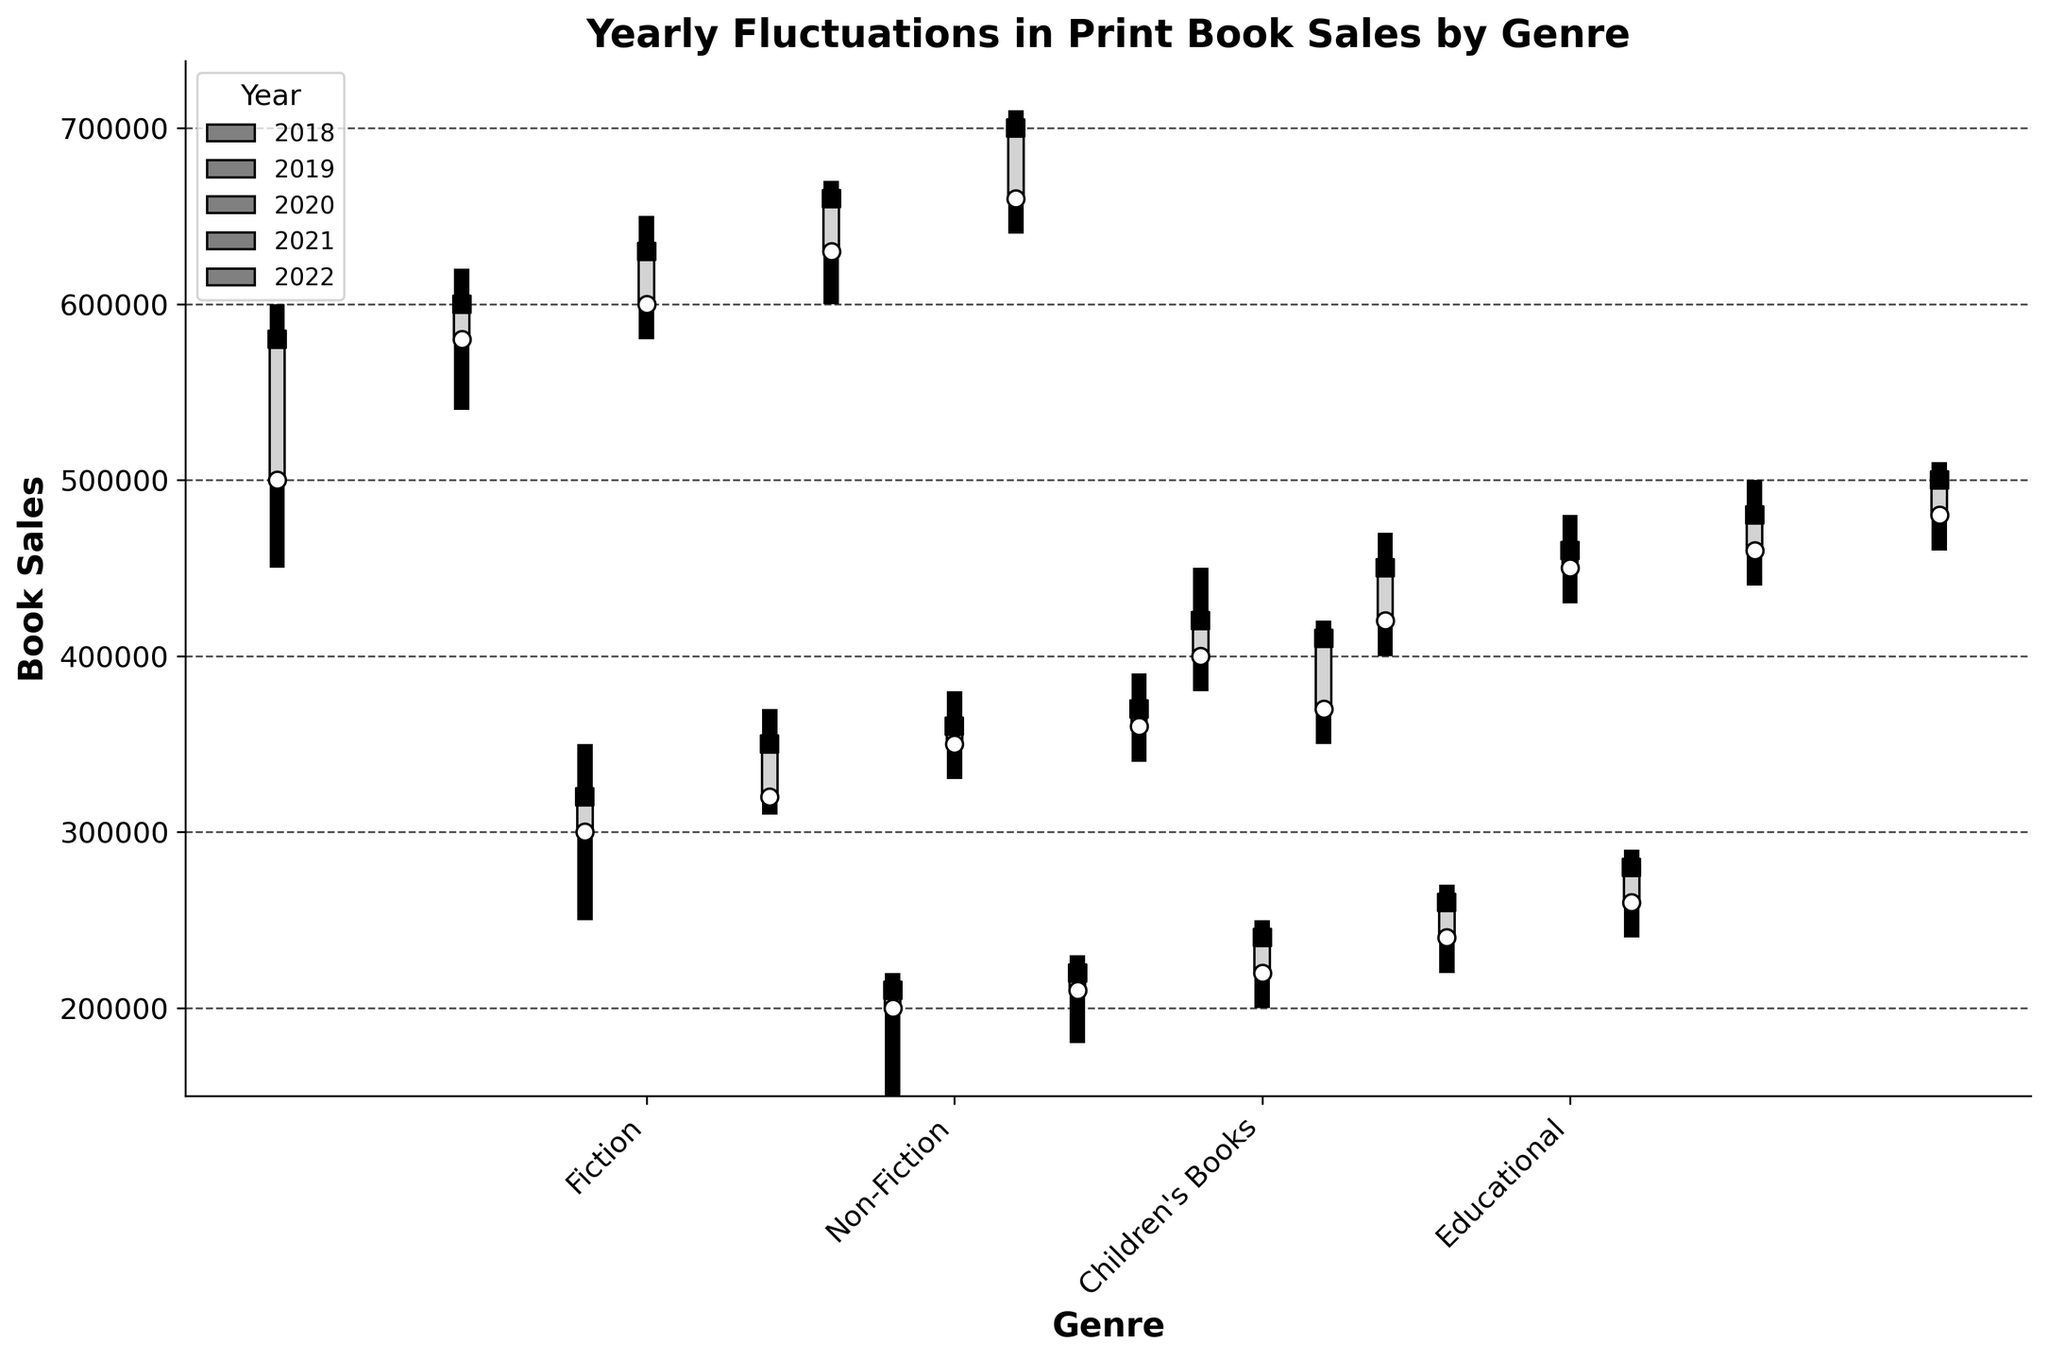What's the title of the plot? The title is indicated at the top of the plot.
Answer: Yearly Fluctuations in Print Book Sales by Genre What is the y-axis label? The y-axis label is shown on the left side of the plot.
Answer: Book Sales What genre had the highest sales in 2022? By examining the candlesticks for 2022, the genre with the highest close value is noted. Fiction ended at 700,000, which is the highest.
Answer: Fiction In which year did Educational books have the lowest close value? Look at the close values (square markers) for Educational across all years. The lowest close value is in 2018 and is 420,000.
Answer: 2018 Did Children's Books sales increase or decrease between 2021 and 2022? Compare the close values for Children's Books in 2021 (260,000) and 2022 (280,000). The sales increased.
Answer: Increase Which genre had the narrowest yearly range (high-low) in 2018? Calculate the high-low range for all genres in 2018 and determine the smallest value. Children's Books had a range of 70,000 (220,000 - 150,000).
Answer: Children's Books Is there a genre where the opening value was higher than the closing value in all the years? Examine each genre's open and close values across all years. For Non-Fiction, in every year examined, the opening value was lower than the closing value.
Answer: No What is the difference between the highest and lowest closing values of Fiction books over the years? Find the highest close value (700,000 in 2022) and the lowest close value (580,000 in 2018) of Fiction books. The difference is 700,000 - 580,000 = 120,000.
Answer: 120,000 Which genres showed consistent year-over-year growth in their closing values? Check the close values of each genre over the years to see if they are continuously increasing. Fiction and Educational books show consistent growth each year.
Answer: Fiction, Educational 